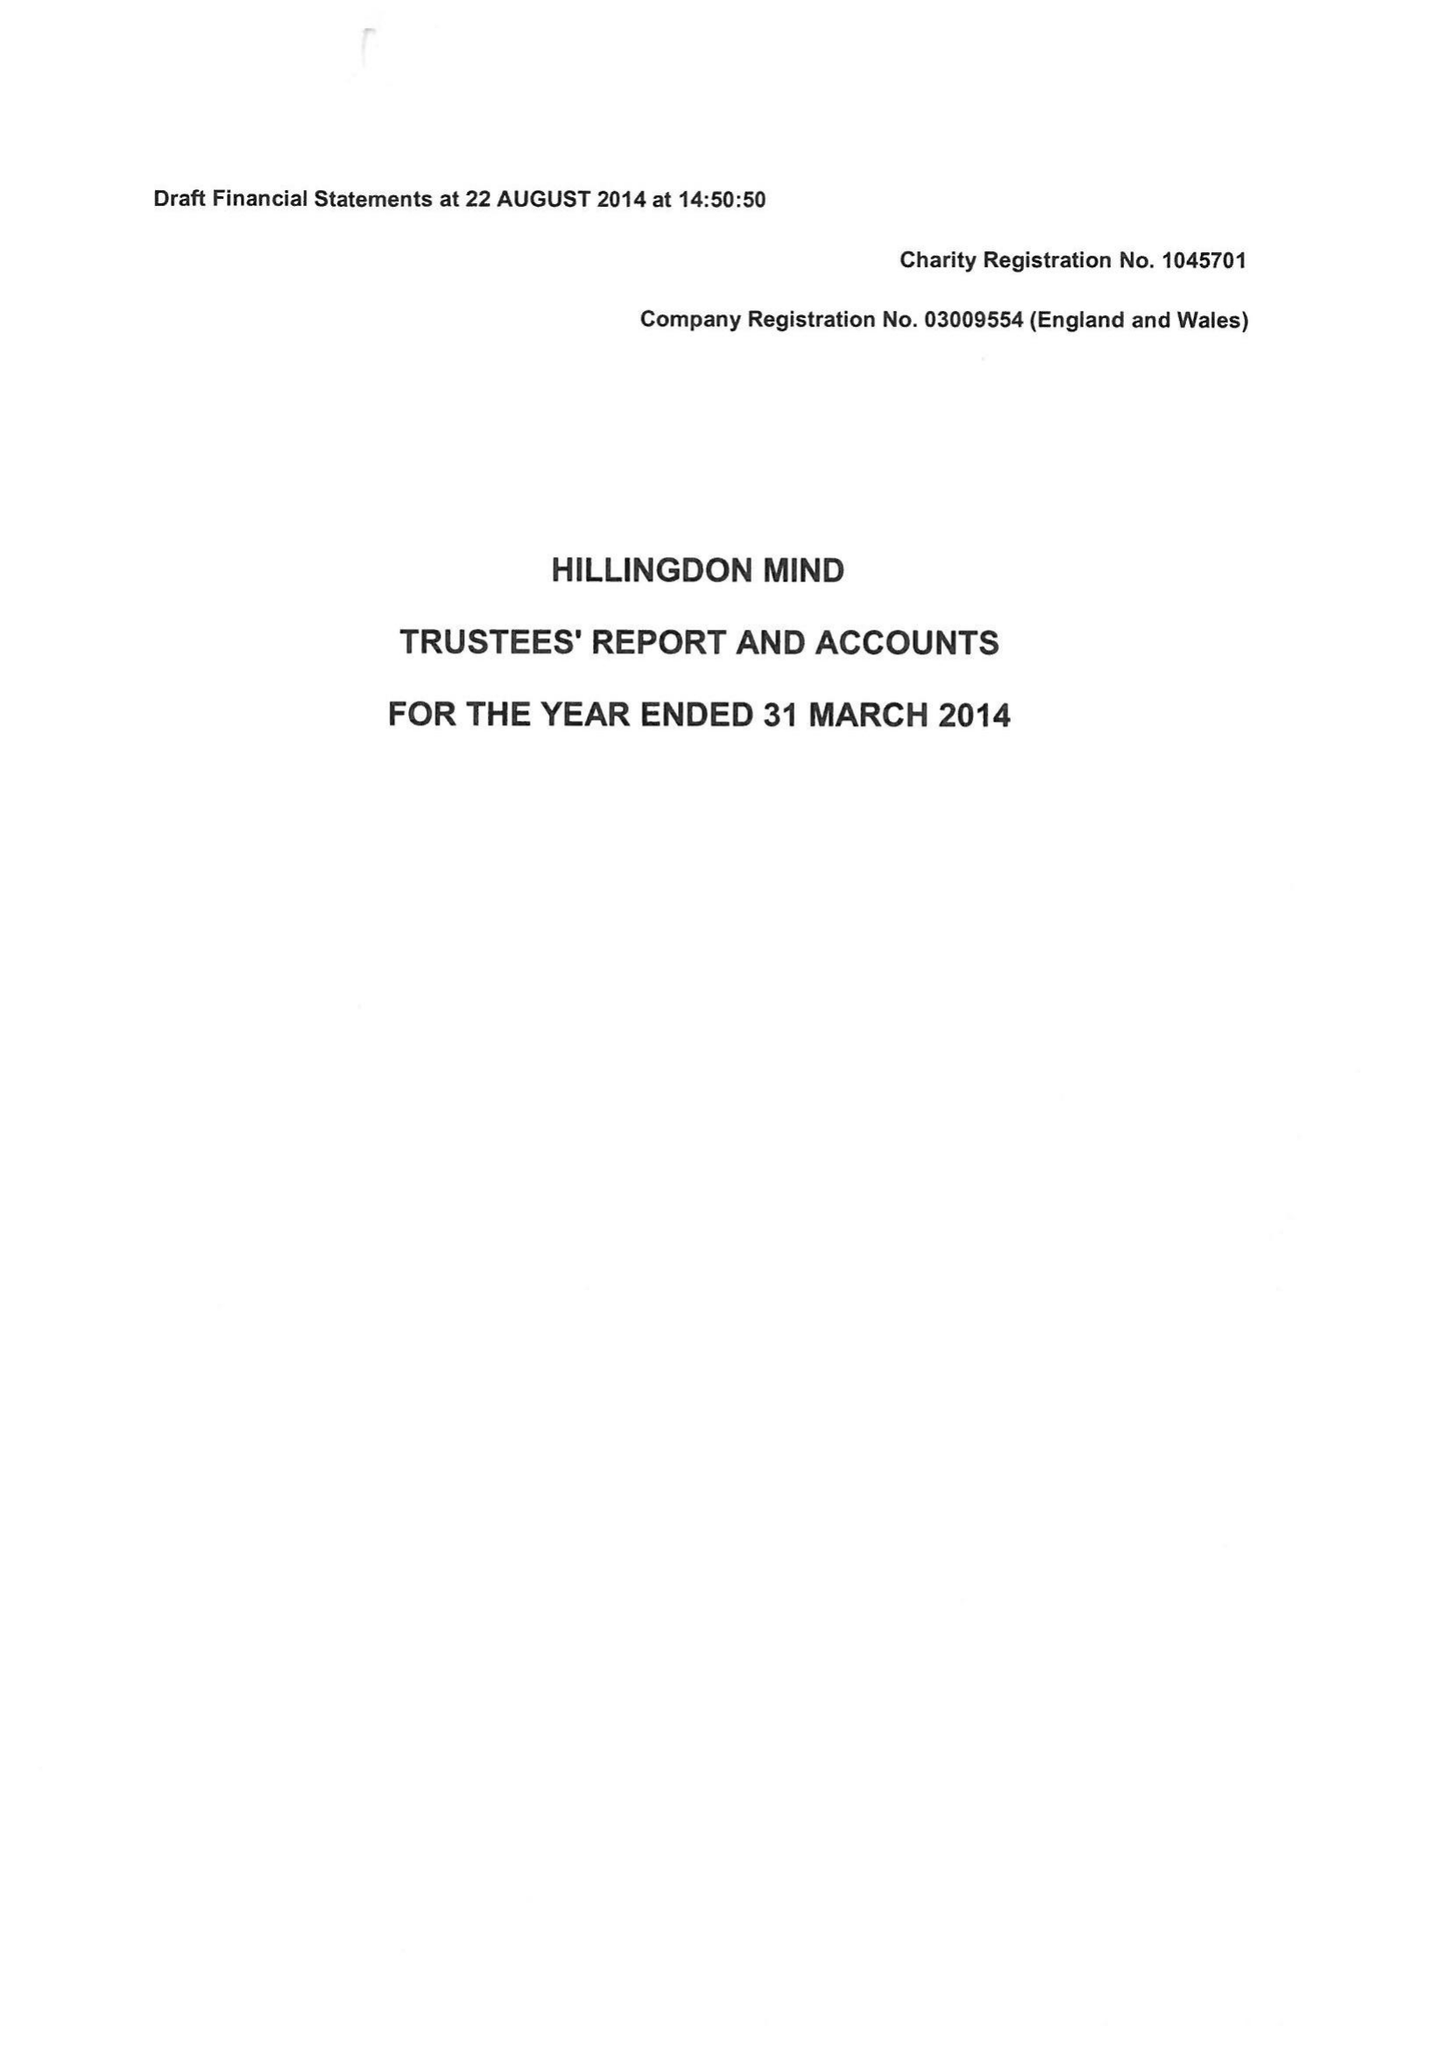What is the value for the report_date?
Answer the question using a single word or phrase. 2014-03-31 